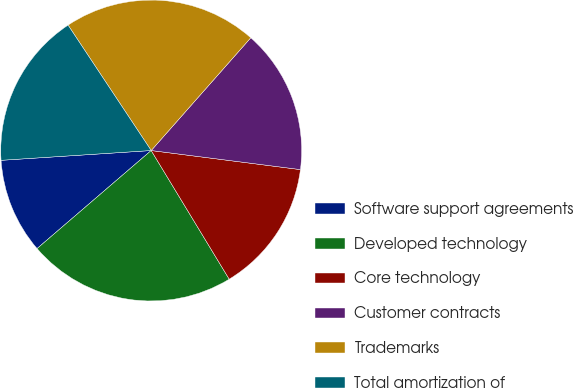<chart> <loc_0><loc_0><loc_500><loc_500><pie_chart><fcel>Software support agreements<fcel>Developed technology<fcel>Core technology<fcel>Customer contracts<fcel>Trademarks<fcel>Total amortization of<nl><fcel>10.26%<fcel>22.38%<fcel>14.3%<fcel>15.51%<fcel>20.83%<fcel>16.72%<nl></chart> 